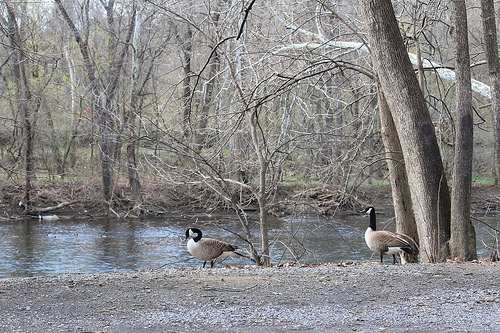<image>
Can you confirm if the goose is in front of the river? Yes. The goose is positioned in front of the river, appearing closer to the camera viewpoint. 